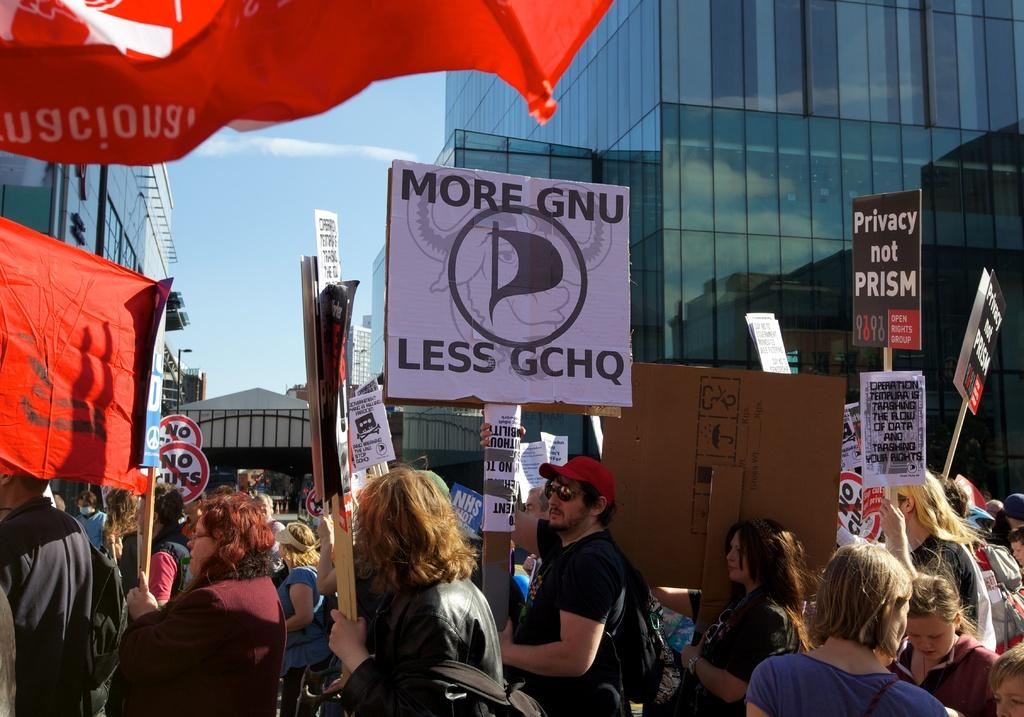What are the persons in the image holding? The persons in the image are holding hoarding boards. What can be seen in the background of the image? There are buildings, glass doors, poles, trees, a fence, and clouds in the sky in the background of the image. Can you see any fairies flying around the persons holding hoarding boards in the image? No, there are no fairies present in the image. What time is it according to the clock in the image? There is no clock present in the image. 